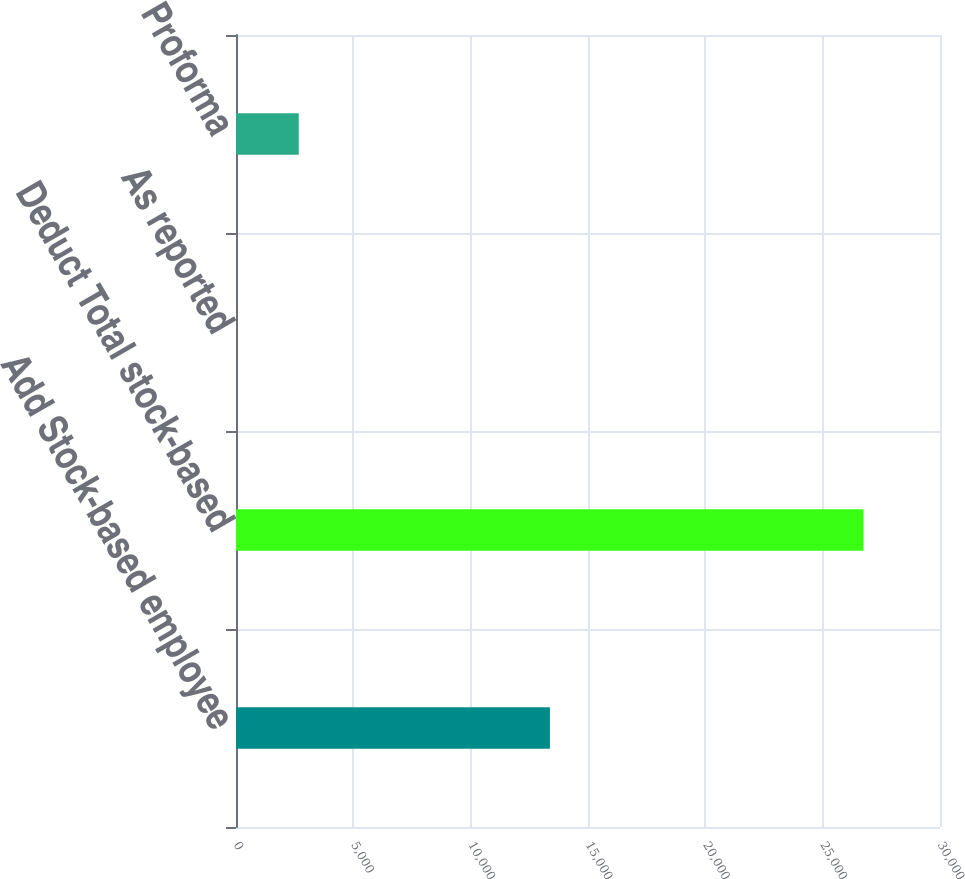<chart> <loc_0><loc_0><loc_500><loc_500><bar_chart><fcel>Add Stock-based employee<fcel>Deduct Total stock-based<fcel>As reported<fcel>Proforma<nl><fcel>13378<fcel>26742<fcel>0.35<fcel>2674.52<nl></chart> 